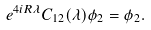<formula> <loc_0><loc_0><loc_500><loc_500>e ^ { 4 i R \lambda } C _ { 1 2 } ( \lambda ) \phi _ { 2 } = \phi _ { 2 } .</formula> 